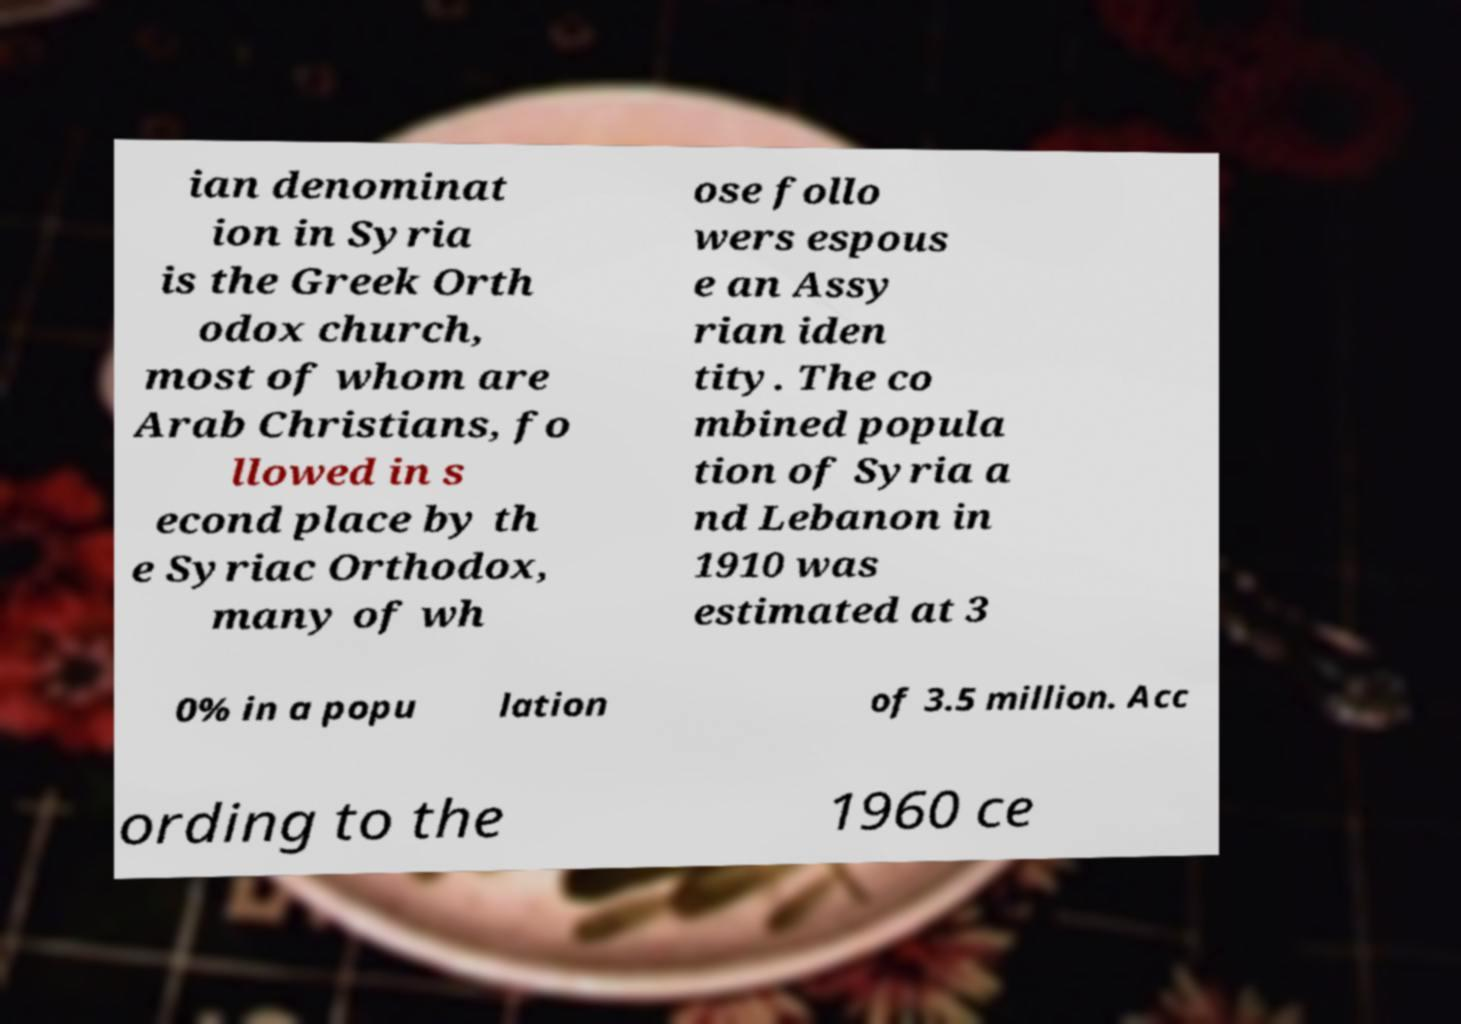Please read and relay the text visible in this image. What does it say? ian denominat ion in Syria is the Greek Orth odox church, most of whom are Arab Christians, fo llowed in s econd place by th e Syriac Orthodox, many of wh ose follo wers espous e an Assy rian iden tity. The co mbined popula tion of Syria a nd Lebanon in 1910 was estimated at 3 0% in a popu lation of 3.5 million. Acc ording to the 1960 ce 